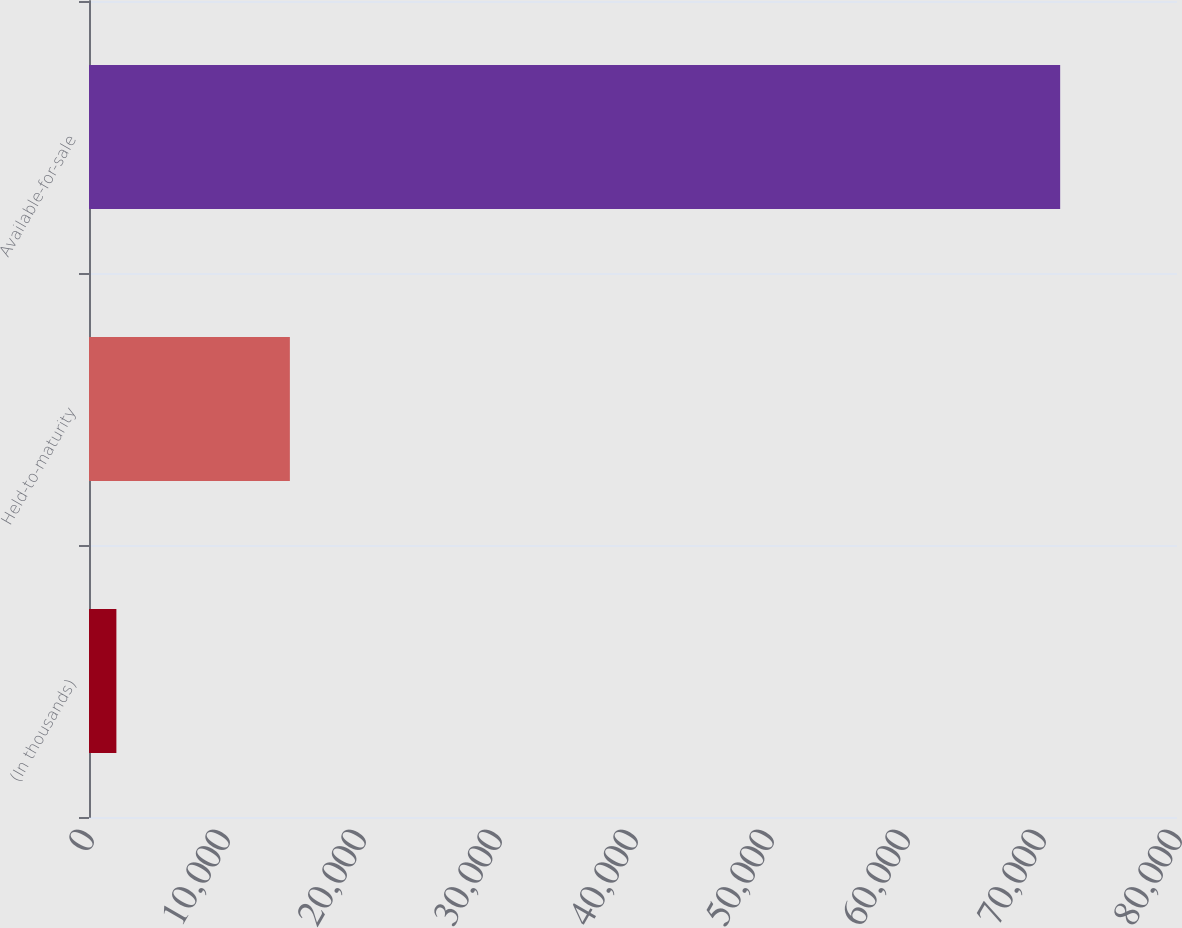Convert chart. <chart><loc_0><loc_0><loc_500><loc_500><bar_chart><fcel>(In thousands)<fcel>Held-to-maturity<fcel>Available-for-sale<nl><fcel>2014<fcel>14770<fcel>71409<nl></chart> 